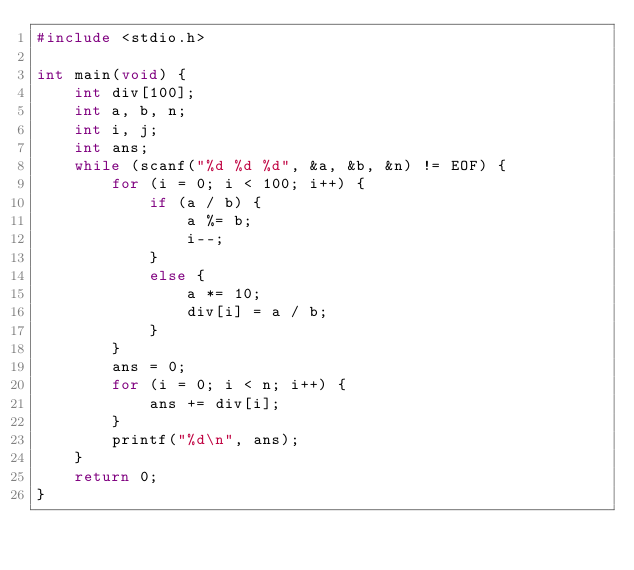<code> <loc_0><loc_0><loc_500><loc_500><_C_>#include <stdio.h>

int main(void) {
	int div[100];
	int a, b, n;
	int i, j;
	int ans;
	while (scanf("%d %d %d", &a, &b, &n) != EOF) {
		for (i = 0; i < 100; i++) {
			if (a / b) {
				a %= b;
				i--;
			}
			else {
				a *= 10;
				div[i] = a / b;
			}
		}
		ans = 0;
		for (i = 0; i < n; i++) {
			ans += div[i];
		}
		printf("%d\n", ans);
	}
	return 0;
}</code> 